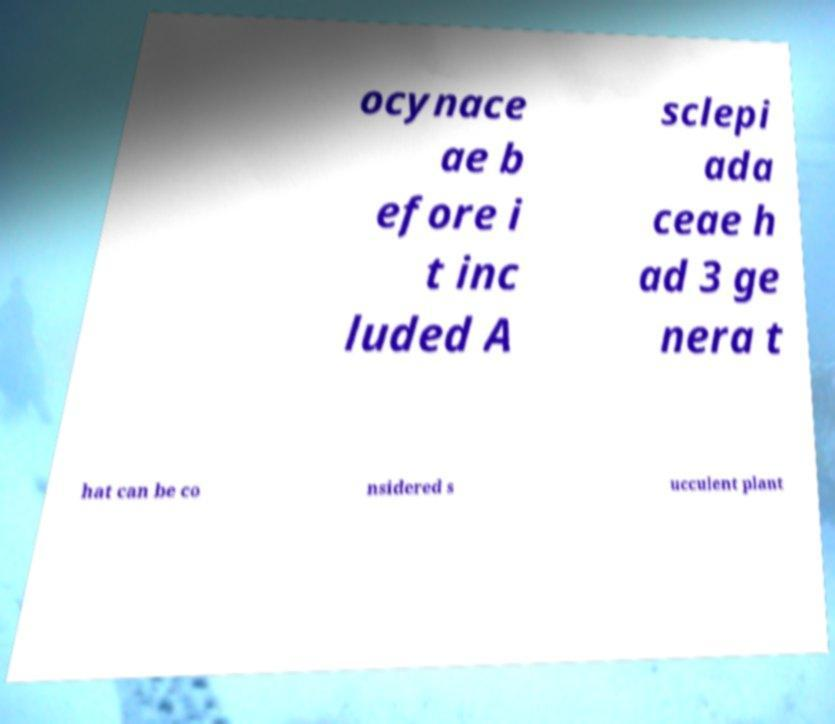Please read and relay the text visible in this image. What does it say? ocynace ae b efore i t inc luded A sclepi ada ceae h ad 3 ge nera t hat can be co nsidered s ucculent plant 